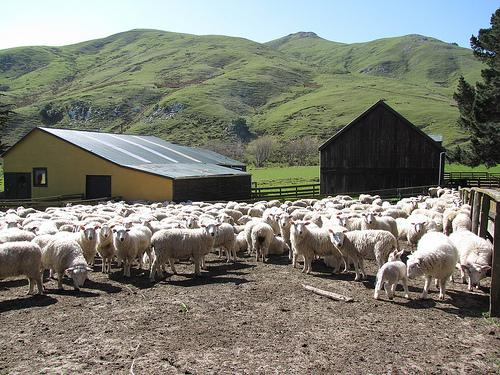How does the sky appear in this image? The sky is blue and clear with no clouds visible. How many types of buildings are in the image and describe one of them. There are two types of buildings: a yellow house and a dark wooden barn. The barn has a sloping roof and a small window on the side. What kind of tree can you see in the image and describe how it looks? There is a tall dark green tree with thick branches, which appears to be a leafy pine tree. What natural elements can you spot in the image, and what colors do they have? The natural elements in the image include green hills, dark green trees, and grass-covered fields. The sky is pale blue, and the ground has patches of brown dirt. What material are the fence and the barn made of? Both the fence and the barn are made of dark wood. How would you describe the landscape in the image? The landscape consists of rolling green hills, a pale blue sky and a field of dirt, filled with a herd of white sheep, dark green trees, and a small yellow house. Identify the primary elements of the sheep pen and describe its environment. The sheep pen consists of a group of white sheep, some fluffy haired, fenced with dark wooden materials. It is surrounded by dirt-covered ground and located near a small yellow house. Count and describe the sheep in the image, including their appearance and behavior. There are many white sheep, some fluffy-haired, including three individuals looking in the same direction and one lamb between two adult sheep. They are all part of a flock in the sheep pen. What kind of building can you see in the scene and what is unique about it? There is a small yellow building with a dark roof and a small square window, located near the sheep pen and surrounded by green vegetation. List three objects that can be found on the ground in the image. A piece of wood, shadows, and a log are objects found on the ground. Detect any text present in the image. There is no visible text in the image. Look for a group of children playing soccer on the rough brown dirt, they are wearing red and blue uniforms. The instructions are misleading as there are no children or any sport-related objects in the image. The image focuses on natural scenery, animals, and buildings, so a group of children playing soccer would be out of context. Describe the attributes of the tree. The tree is tall, dark green, and has thick branches. Choose the correct option: (a) The sky is pink and cloudy, (b) The sky is blue and clear. (b) The sky is blue and clear. Have you noticed the red sports car parked next to the small brown house? It has shiny rims and a sleek design. The instructions are misleading because there is no mention of any vehicle in the image. The image focuses on sheep, buildings, and natural scenery, so introducing a car would not fit the context of the image. What is the material of the fence? The fence is wooden. Can you spot the pink elephant near the tree? It has a large trunk and big ears. No, it's not mentioned in the image. What is the overall sentiment or mood portrayed in this image? The overall sentiment of the image is peaceful and serene. Identify the color of the building and its roof. The building is yellow and the roof is dark. Is there a lamb with two adult sheep in the image? Yes, there is a lamb in the middle of two adult sheep. Determine the types of ground cover in the image. There are bright green grass, rough brown dirt, and dirt-covered ground. Near the wooden fence, there is a small pond with ducks swimming in it. Can you see them? The instructions are misleading as there is no mention of any water body or birds such as ducks in the image. The image is about sheep, buildings, and natural scenery, so mentioning ducks in a pond is out of context. Assess the quality of this image. The image is of good quality with clear object details and balanced composition. Describe the interaction between the objects in the image. The sheep are in the pen near the small yellow house, while the hills and trees are in the background. Describe the terrain in the image. The terrain includes rolling green hills, dark-green trees, and a dirt field. Explain the surroundings of the pen. The pen is surrounded by a wooden fence, some sheep, a small yellow house, and a dirt field. Find any anomalies present in the image. There are no significant anomalies detected in the image. How many sheep can you see in the image? There is a herd of white sheep. Which object can be seen at position X:33 Y:167 Width:14 Height:14? A small square window. What kind of roof does the small yellow house have? The small yellow house has a dark roof. What is the color of the sky in the image? The sky is pale blue. Match the captions of "a flock of sheeps" to their corresponding objects in the image. A flock of sheeps matches the group at X:0 Y:196 Width:499 Height:499. Is there a log or a piece of wood on the ground? Yes, there is a piece of wood on the ground. Are there any buildings in the image? If so, describe them. Yes, there is a small yellow house and a dark wooden barn with a sloping roof. 